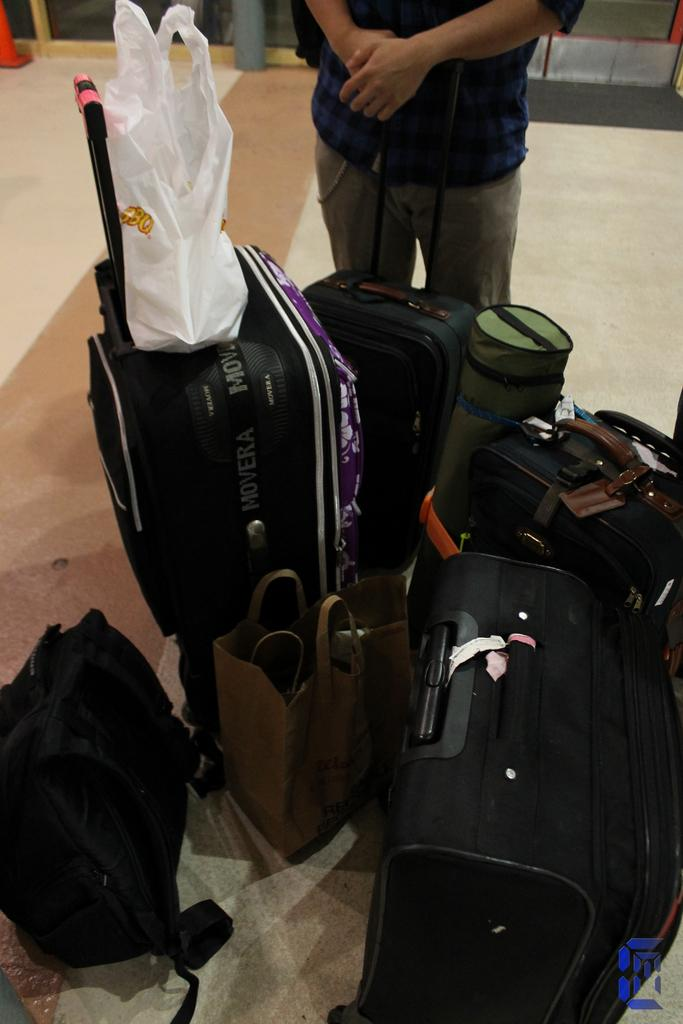What is on the ground in the image? There are bags on the ground. What is the person in the image doing? The person is standing and holding a bag. What can be seen in the background of the image? There is a wall and a gray pipe in the background. Are there any cherries visible in the image? No, there are no cherries present in the image. Does the person in the image appear to be disgusted by the bags on the ground? The image does not provide any information about the person's emotions or reactions, so it cannot be determined if they are disgusted or not. 